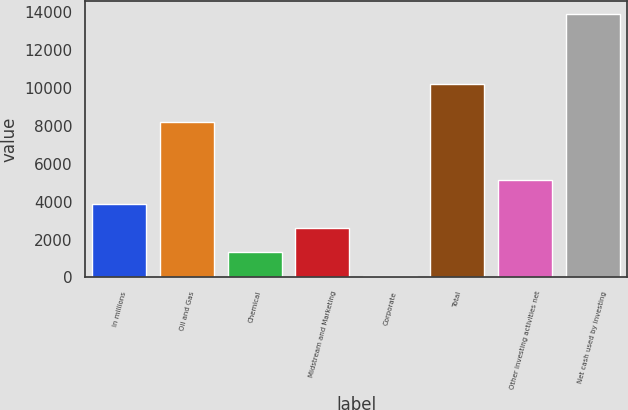<chart> <loc_0><loc_0><loc_500><loc_500><bar_chart><fcel>In millions<fcel>Oil and Gas<fcel>Chemical<fcel>Midstream and Marketing<fcel>Corporate<fcel>Total<fcel>Other investing activities net<fcel>Net cash used by investing<nl><fcel>3860.2<fcel>8220<fcel>1347.4<fcel>2603.8<fcel>91<fcel>10226<fcel>5116.6<fcel>13911.4<nl></chart> 